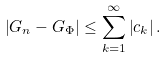Convert formula to latex. <formula><loc_0><loc_0><loc_500><loc_500>\left | G _ { n } - G _ { \Phi } \right | \leq \sum _ { k = 1 } ^ { \infty } \left | c _ { k } \right | .</formula> 